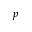Convert formula to latex. <formula><loc_0><loc_0><loc_500><loc_500>p</formula> 